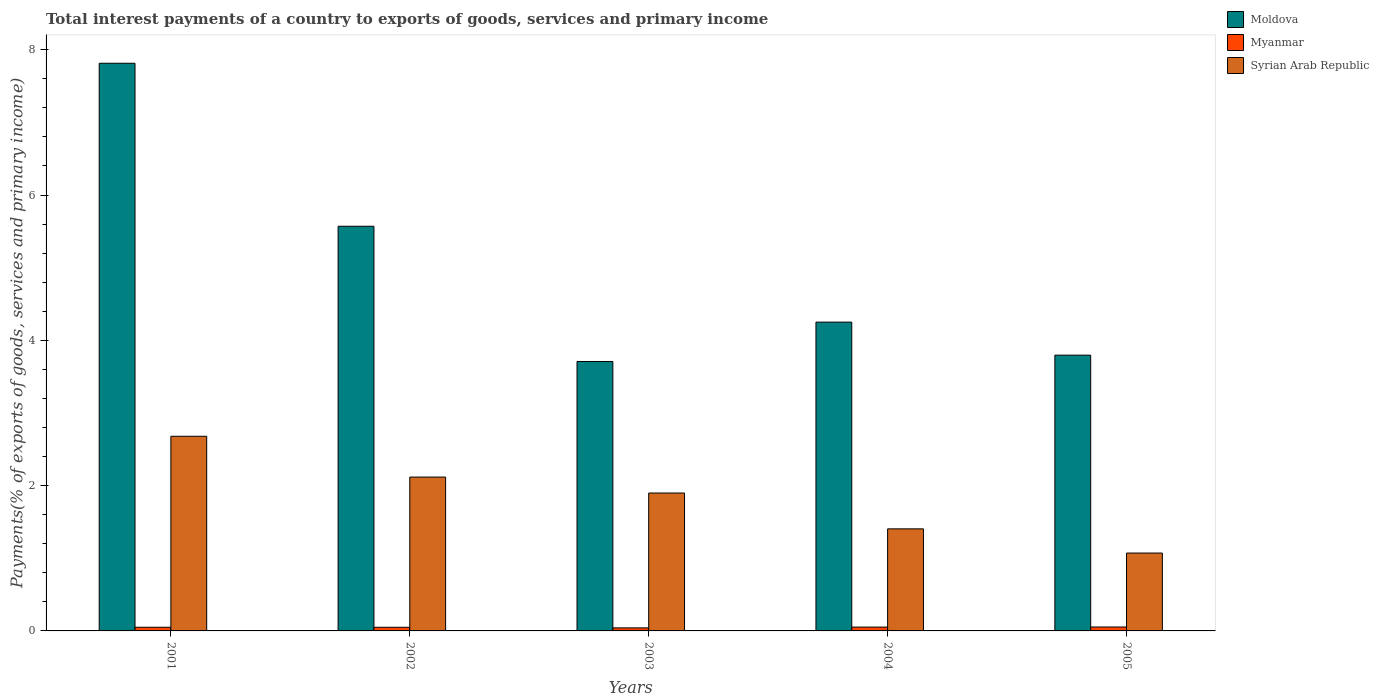How many different coloured bars are there?
Provide a short and direct response. 3. Are the number of bars per tick equal to the number of legend labels?
Your answer should be compact. Yes. Are the number of bars on each tick of the X-axis equal?
Give a very brief answer. Yes. How many bars are there on the 2nd tick from the left?
Keep it short and to the point. 3. What is the total interest payments in Syrian Arab Republic in 2001?
Offer a very short reply. 2.68. Across all years, what is the maximum total interest payments in Myanmar?
Ensure brevity in your answer.  0.05. Across all years, what is the minimum total interest payments in Moldova?
Offer a very short reply. 3.71. What is the total total interest payments in Moldova in the graph?
Make the answer very short. 25.14. What is the difference between the total interest payments in Myanmar in 2002 and that in 2004?
Offer a terse response. -0. What is the difference between the total interest payments in Moldova in 2002 and the total interest payments in Syrian Arab Republic in 2004?
Offer a very short reply. 4.16. What is the average total interest payments in Myanmar per year?
Your answer should be compact. 0.05. In the year 2004, what is the difference between the total interest payments in Myanmar and total interest payments in Moldova?
Your response must be concise. -4.2. In how many years, is the total interest payments in Myanmar greater than 2 %?
Ensure brevity in your answer.  0. What is the ratio of the total interest payments in Syrian Arab Republic in 2003 to that in 2004?
Make the answer very short. 1.35. Is the difference between the total interest payments in Myanmar in 2004 and 2005 greater than the difference between the total interest payments in Moldova in 2004 and 2005?
Your answer should be very brief. No. What is the difference between the highest and the second highest total interest payments in Syrian Arab Republic?
Offer a terse response. 0.56. What is the difference between the highest and the lowest total interest payments in Myanmar?
Your response must be concise. 0.01. In how many years, is the total interest payments in Moldova greater than the average total interest payments in Moldova taken over all years?
Your response must be concise. 2. Is the sum of the total interest payments in Moldova in 2002 and 2004 greater than the maximum total interest payments in Syrian Arab Republic across all years?
Your answer should be compact. Yes. What does the 3rd bar from the left in 2001 represents?
Offer a terse response. Syrian Arab Republic. What does the 1st bar from the right in 2001 represents?
Ensure brevity in your answer.  Syrian Arab Republic. Is it the case that in every year, the sum of the total interest payments in Syrian Arab Republic and total interest payments in Myanmar is greater than the total interest payments in Moldova?
Ensure brevity in your answer.  No. Are all the bars in the graph horizontal?
Offer a very short reply. No. Does the graph contain any zero values?
Make the answer very short. No. Does the graph contain grids?
Keep it short and to the point. No. How are the legend labels stacked?
Your response must be concise. Vertical. What is the title of the graph?
Keep it short and to the point. Total interest payments of a country to exports of goods, services and primary income. What is the label or title of the Y-axis?
Ensure brevity in your answer.  Payments(% of exports of goods, services and primary income). What is the Payments(% of exports of goods, services and primary income) in Moldova in 2001?
Provide a short and direct response. 7.81. What is the Payments(% of exports of goods, services and primary income) of Myanmar in 2001?
Ensure brevity in your answer.  0.05. What is the Payments(% of exports of goods, services and primary income) of Syrian Arab Republic in 2001?
Keep it short and to the point. 2.68. What is the Payments(% of exports of goods, services and primary income) of Moldova in 2002?
Your response must be concise. 5.57. What is the Payments(% of exports of goods, services and primary income) in Myanmar in 2002?
Your answer should be very brief. 0.05. What is the Payments(% of exports of goods, services and primary income) in Syrian Arab Republic in 2002?
Provide a short and direct response. 2.12. What is the Payments(% of exports of goods, services and primary income) in Moldova in 2003?
Offer a terse response. 3.71. What is the Payments(% of exports of goods, services and primary income) of Myanmar in 2003?
Provide a short and direct response. 0.04. What is the Payments(% of exports of goods, services and primary income) in Syrian Arab Republic in 2003?
Provide a short and direct response. 1.9. What is the Payments(% of exports of goods, services and primary income) in Moldova in 2004?
Make the answer very short. 4.25. What is the Payments(% of exports of goods, services and primary income) of Myanmar in 2004?
Your response must be concise. 0.05. What is the Payments(% of exports of goods, services and primary income) of Syrian Arab Republic in 2004?
Provide a succinct answer. 1.4. What is the Payments(% of exports of goods, services and primary income) in Moldova in 2005?
Ensure brevity in your answer.  3.8. What is the Payments(% of exports of goods, services and primary income) in Myanmar in 2005?
Your answer should be compact. 0.05. What is the Payments(% of exports of goods, services and primary income) in Syrian Arab Republic in 2005?
Ensure brevity in your answer.  1.07. Across all years, what is the maximum Payments(% of exports of goods, services and primary income) of Moldova?
Offer a terse response. 7.81. Across all years, what is the maximum Payments(% of exports of goods, services and primary income) of Myanmar?
Give a very brief answer. 0.05. Across all years, what is the maximum Payments(% of exports of goods, services and primary income) of Syrian Arab Republic?
Give a very brief answer. 2.68. Across all years, what is the minimum Payments(% of exports of goods, services and primary income) in Moldova?
Make the answer very short. 3.71. Across all years, what is the minimum Payments(% of exports of goods, services and primary income) of Myanmar?
Provide a succinct answer. 0.04. Across all years, what is the minimum Payments(% of exports of goods, services and primary income) in Syrian Arab Republic?
Make the answer very short. 1.07. What is the total Payments(% of exports of goods, services and primary income) in Moldova in the graph?
Offer a very short reply. 25.14. What is the total Payments(% of exports of goods, services and primary income) in Myanmar in the graph?
Ensure brevity in your answer.  0.25. What is the total Payments(% of exports of goods, services and primary income) in Syrian Arab Republic in the graph?
Your answer should be compact. 9.17. What is the difference between the Payments(% of exports of goods, services and primary income) of Moldova in 2001 and that in 2002?
Offer a very short reply. 2.24. What is the difference between the Payments(% of exports of goods, services and primary income) of Myanmar in 2001 and that in 2002?
Offer a very short reply. 0. What is the difference between the Payments(% of exports of goods, services and primary income) of Syrian Arab Republic in 2001 and that in 2002?
Your answer should be compact. 0.56. What is the difference between the Payments(% of exports of goods, services and primary income) in Moldova in 2001 and that in 2003?
Your answer should be compact. 4.11. What is the difference between the Payments(% of exports of goods, services and primary income) of Myanmar in 2001 and that in 2003?
Keep it short and to the point. 0.01. What is the difference between the Payments(% of exports of goods, services and primary income) in Syrian Arab Republic in 2001 and that in 2003?
Your response must be concise. 0.78. What is the difference between the Payments(% of exports of goods, services and primary income) in Moldova in 2001 and that in 2004?
Offer a very short reply. 3.56. What is the difference between the Payments(% of exports of goods, services and primary income) of Myanmar in 2001 and that in 2004?
Your response must be concise. -0. What is the difference between the Payments(% of exports of goods, services and primary income) of Syrian Arab Republic in 2001 and that in 2004?
Ensure brevity in your answer.  1.27. What is the difference between the Payments(% of exports of goods, services and primary income) in Moldova in 2001 and that in 2005?
Make the answer very short. 4.02. What is the difference between the Payments(% of exports of goods, services and primary income) of Myanmar in 2001 and that in 2005?
Offer a very short reply. -0. What is the difference between the Payments(% of exports of goods, services and primary income) in Syrian Arab Republic in 2001 and that in 2005?
Keep it short and to the point. 1.61. What is the difference between the Payments(% of exports of goods, services and primary income) in Moldova in 2002 and that in 2003?
Your answer should be very brief. 1.86. What is the difference between the Payments(% of exports of goods, services and primary income) of Myanmar in 2002 and that in 2003?
Give a very brief answer. 0.01. What is the difference between the Payments(% of exports of goods, services and primary income) of Syrian Arab Republic in 2002 and that in 2003?
Provide a succinct answer. 0.22. What is the difference between the Payments(% of exports of goods, services and primary income) in Moldova in 2002 and that in 2004?
Provide a short and direct response. 1.32. What is the difference between the Payments(% of exports of goods, services and primary income) in Myanmar in 2002 and that in 2004?
Make the answer very short. -0. What is the difference between the Payments(% of exports of goods, services and primary income) in Syrian Arab Republic in 2002 and that in 2004?
Ensure brevity in your answer.  0.71. What is the difference between the Payments(% of exports of goods, services and primary income) in Moldova in 2002 and that in 2005?
Offer a terse response. 1.77. What is the difference between the Payments(% of exports of goods, services and primary income) in Myanmar in 2002 and that in 2005?
Keep it short and to the point. -0. What is the difference between the Payments(% of exports of goods, services and primary income) of Syrian Arab Republic in 2002 and that in 2005?
Your answer should be compact. 1.05. What is the difference between the Payments(% of exports of goods, services and primary income) of Moldova in 2003 and that in 2004?
Keep it short and to the point. -0.54. What is the difference between the Payments(% of exports of goods, services and primary income) in Myanmar in 2003 and that in 2004?
Offer a terse response. -0.01. What is the difference between the Payments(% of exports of goods, services and primary income) in Syrian Arab Republic in 2003 and that in 2004?
Ensure brevity in your answer.  0.49. What is the difference between the Payments(% of exports of goods, services and primary income) in Moldova in 2003 and that in 2005?
Offer a terse response. -0.09. What is the difference between the Payments(% of exports of goods, services and primary income) in Myanmar in 2003 and that in 2005?
Provide a succinct answer. -0.01. What is the difference between the Payments(% of exports of goods, services and primary income) in Syrian Arab Republic in 2003 and that in 2005?
Give a very brief answer. 0.83. What is the difference between the Payments(% of exports of goods, services and primary income) of Moldova in 2004 and that in 2005?
Offer a very short reply. 0.45. What is the difference between the Payments(% of exports of goods, services and primary income) in Myanmar in 2004 and that in 2005?
Keep it short and to the point. -0. What is the difference between the Payments(% of exports of goods, services and primary income) in Syrian Arab Republic in 2004 and that in 2005?
Keep it short and to the point. 0.33. What is the difference between the Payments(% of exports of goods, services and primary income) in Moldova in 2001 and the Payments(% of exports of goods, services and primary income) in Myanmar in 2002?
Provide a short and direct response. 7.76. What is the difference between the Payments(% of exports of goods, services and primary income) of Moldova in 2001 and the Payments(% of exports of goods, services and primary income) of Syrian Arab Republic in 2002?
Provide a short and direct response. 5.7. What is the difference between the Payments(% of exports of goods, services and primary income) in Myanmar in 2001 and the Payments(% of exports of goods, services and primary income) in Syrian Arab Republic in 2002?
Your response must be concise. -2.07. What is the difference between the Payments(% of exports of goods, services and primary income) of Moldova in 2001 and the Payments(% of exports of goods, services and primary income) of Myanmar in 2003?
Make the answer very short. 7.77. What is the difference between the Payments(% of exports of goods, services and primary income) of Moldova in 2001 and the Payments(% of exports of goods, services and primary income) of Syrian Arab Republic in 2003?
Ensure brevity in your answer.  5.92. What is the difference between the Payments(% of exports of goods, services and primary income) in Myanmar in 2001 and the Payments(% of exports of goods, services and primary income) in Syrian Arab Republic in 2003?
Keep it short and to the point. -1.85. What is the difference between the Payments(% of exports of goods, services and primary income) of Moldova in 2001 and the Payments(% of exports of goods, services and primary income) of Myanmar in 2004?
Provide a short and direct response. 7.76. What is the difference between the Payments(% of exports of goods, services and primary income) in Moldova in 2001 and the Payments(% of exports of goods, services and primary income) in Syrian Arab Republic in 2004?
Keep it short and to the point. 6.41. What is the difference between the Payments(% of exports of goods, services and primary income) in Myanmar in 2001 and the Payments(% of exports of goods, services and primary income) in Syrian Arab Republic in 2004?
Keep it short and to the point. -1.35. What is the difference between the Payments(% of exports of goods, services and primary income) of Moldova in 2001 and the Payments(% of exports of goods, services and primary income) of Myanmar in 2005?
Provide a short and direct response. 7.76. What is the difference between the Payments(% of exports of goods, services and primary income) in Moldova in 2001 and the Payments(% of exports of goods, services and primary income) in Syrian Arab Republic in 2005?
Your answer should be very brief. 6.74. What is the difference between the Payments(% of exports of goods, services and primary income) in Myanmar in 2001 and the Payments(% of exports of goods, services and primary income) in Syrian Arab Republic in 2005?
Provide a succinct answer. -1.02. What is the difference between the Payments(% of exports of goods, services and primary income) of Moldova in 2002 and the Payments(% of exports of goods, services and primary income) of Myanmar in 2003?
Make the answer very short. 5.53. What is the difference between the Payments(% of exports of goods, services and primary income) in Moldova in 2002 and the Payments(% of exports of goods, services and primary income) in Syrian Arab Republic in 2003?
Give a very brief answer. 3.67. What is the difference between the Payments(% of exports of goods, services and primary income) in Myanmar in 2002 and the Payments(% of exports of goods, services and primary income) in Syrian Arab Republic in 2003?
Offer a very short reply. -1.85. What is the difference between the Payments(% of exports of goods, services and primary income) of Moldova in 2002 and the Payments(% of exports of goods, services and primary income) of Myanmar in 2004?
Your response must be concise. 5.52. What is the difference between the Payments(% of exports of goods, services and primary income) of Moldova in 2002 and the Payments(% of exports of goods, services and primary income) of Syrian Arab Republic in 2004?
Keep it short and to the point. 4.17. What is the difference between the Payments(% of exports of goods, services and primary income) in Myanmar in 2002 and the Payments(% of exports of goods, services and primary income) in Syrian Arab Republic in 2004?
Your answer should be compact. -1.35. What is the difference between the Payments(% of exports of goods, services and primary income) of Moldova in 2002 and the Payments(% of exports of goods, services and primary income) of Myanmar in 2005?
Provide a succinct answer. 5.52. What is the difference between the Payments(% of exports of goods, services and primary income) in Moldova in 2002 and the Payments(% of exports of goods, services and primary income) in Syrian Arab Republic in 2005?
Make the answer very short. 4.5. What is the difference between the Payments(% of exports of goods, services and primary income) of Myanmar in 2002 and the Payments(% of exports of goods, services and primary income) of Syrian Arab Republic in 2005?
Offer a very short reply. -1.02. What is the difference between the Payments(% of exports of goods, services and primary income) in Moldova in 2003 and the Payments(% of exports of goods, services and primary income) in Myanmar in 2004?
Your answer should be compact. 3.66. What is the difference between the Payments(% of exports of goods, services and primary income) of Moldova in 2003 and the Payments(% of exports of goods, services and primary income) of Syrian Arab Republic in 2004?
Your answer should be very brief. 2.3. What is the difference between the Payments(% of exports of goods, services and primary income) in Myanmar in 2003 and the Payments(% of exports of goods, services and primary income) in Syrian Arab Republic in 2004?
Offer a terse response. -1.36. What is the difference between the Payments(% of exports of goods, services and primary income) of Moldova in 2003 and the Payments(% of exports of goods, services and primary income) of Myanmar in 2005?
Offer a very short reply. 3.65. What is the difference between the Payments(% of exports of goods, services and primary income) of Moldova in 2003 and the Payments(% of exports of goods, services and primary income) of Syrian Arab Republic in 2005?
Your answer should be very brief. 2.64. What is the difference between the Payments(% of exports of goods, services and primary income) in Myanmar in 2003 and the Payments(% of exports of goods, services and primary income) in Syrian Arab Republic in 2005?
Your response must be concise. -1.03. What is the difference between the Payments(% of exports of goods, services and primary income) of Moldova in 2004 and the Payments(% of exports of goods, services and primary income) of Myanmar in 2005?
Offer a very short reply. 4.2. What is the difference between the Payments(% of exports of goods, services and primary income) of Moldova in 2004 and the Payments(% of exports of goods, services and primary income) of Syrian Arab Republic in 2005?
Make the answer very short. 3.18. What is the difference between the Payments(% of exports of goods, services and primary income) of Myanmar in 2004 and the Payments(% of exports of goods, services and primary income) of Syrian Arab Republic in 2005?
Offer a very short reply. -1.02. What is the average Payments(% of exports of goods, services and primary income) of Moldova per year?
Offer a very short reply. 5.03. What is the average Payments(% of exports of goods, services and primary income) in Myanmar per year?
Provide a succinct answer. 0.05. What is the average Payments(% of exports of goods, services and primary income) of Syrian Arab Republic per year?
Your answer should be very brief. 1.83. In the year 2001, what is the difference between the Payments(% of exports of goods, services and primary income) in Moldova and Payments(% of exports of goods, services and primary income) in Myanmar?
Keep it short and to the point. 7.76. In the year 2001, what is the difference between the Payments(% of exports of goods, services and primary income) of Moldova and Payments(% of exports of goods, services and primary income) of Syrian Arab Republic?
Provide a short and direct response. 5.13. In the year 2001, what is the difference between the Payments(% of exports of goods, services and primary income) in Myanmar and Payments(% of exports of goods, services and primary income) in Syrian Arab Republic?
Ensure brevity in your answer.  -2.63. In the year 2002, what is the difference between the Payments(% of exports of goods, services and primary income) in Moldova and Payments(% of exports of goods, services and primary income) in Myanmar?
Provide a succinct answer. 5.52. In the year 2002, what is the difference between the Payments(% of exports of goods, services and primary income) of Moldova and Payments(% of exports of goods, services and primary income) of Syrian Arab Republic?
Ensure brevity in your answer.  3.45. In the year 2002, what is the difference between the Payments(% of exports of goods, services and primary income) in Myanmar and Payments(% of exports of goods, services and primary income) in Syrian Arab Republic?
Provide a short and direct response. -2.07. In the year 2003, what is the difference between the Payments(% of exports of goods, services and primary income) of Moldova and Payments(% of exports of goods, services and primary income) of Myanmar?
Make the answer very short. 3.67. In the year 2003, what is the difference between the Payments(% of exports of goods, services and primary income) in Moldova and Payments(% of exports of goods, services and primary income) in Syrian Arab Republic?
Your answer should be very brief. 1.81. In the year 2003, what is the difference between the Payments(% of exports of goods, services and primary income) in Myanmar and Payments(% of exports of goods, services and primary income) in Syrian Arab Republic?
Make the answer very short. -1.86. In the year 2004, what is the difference between the Payments(% of exports of goods, services and primary income) of Moldova and Payments(% of exports of goods, services and primary income) of Myanmar?
Your answer should be compact. 4.2. In the year 2004, what is the difference between the Payments(% of exports of goods, services and primary income) in Moldova and Payments(% of exports of goods, services and primary income) in Syrian Arab Republic?
Offer a very short reply. 2.85. In the year 2004, what is the difference between the Payments(% of exports of goods, services and primary income) in Myanmar and Payments(% of exports of goods, services and primary income) in Syrian Arab Republic?
Your response must be concise. -1.35. In the year 2005, what is the difference between the Payments(% of exports of goods, services and primary income) of Moldova and Payments(% of exports of goods, services and primary income) of Myanmar?
Ensure brevity in your answer.  3.74. In the year 2005, what is the difference between the Payments(% of exports of goods, services and primary income) of Moldova and Payments(% of exports of goods, services and primary income) of Syrian Arab Republic?
Make the answer very short. 2.72. In the year 2005, what is the difference between the Payments(% of exports of goods, services and primary income) of Myanmar and Payments(% of exports of goods, services and primary income) of Syrian Arab Republic?
Your answer should be very brief. -1.02. What is the ratio of the Payments(% of exports of goods, services and primary income) of Moldova in 2001 to that in 2002?
Ensure brevity in your answer.  1.4. What is the ratio of the Payments(% of exports of goods, services and primary income) in Myanmar in 2001 to that in 2002?
Ensure brevity in your answer.  1.01. What is the ratio of the Payments(% of exports of goods, services and primary income) of Syrian Arab Republic in 2001 to that in 2002?
Give a very brief answer. 1.27. What is the ratio of the Payments(% of exports of goods, services and primary income) of Moldova in 2001 to that in 2003?
Ensure brevity in your answer.  2.11. What is the ratio of the Payments(% of exports of goods, services and primary income) in Myanmar in 2001 to that in 2003?
Give a very brief answer. 1.2. What is the ratio of the Payments(% of exports of goods, services and primary income) of Syrian Arab Republic in 2001 to that in 2003?
Ensure brevity in your answer.  1.41. What is the ratio of the Payments(% of exports of goods, services and primary income) of Moldova in 2001 to that in 2004?
Ensure brevity in your answer.  1.84. What is the ratio of the Payments(% of exports of goods, services and primary income) of Myanmar in 2001 to that in 2004?
Provide a short and direct response. 0.96. What is the ratio of the Payments(% of exports of goods, services and primary income) in Syrian Arab Republic in 2001 to that in 2004?
Your answer should be very brief. 1.91. What is the ratio of the Payments(% of exports of goods, services and primary income) of Moldova in 2001 to that in 2005?
Give a very brief answer. 2.06. What is the ratio of the Payments(% of exports of goods, services and primary income) of Myanmar in 2001 to that in 2005?
Offer a very short reply. 0.93. What is the ratio of the Payments(% of exports of goods, services and primary income) in Syrian Arab Republic in 2001 to that in 2005?
Your answer should be very brief. 2.5. What is the ratio of the Payments(% of exports of goods, services and primary income) in Moldova in 2002 to that in 2003?
Your response must be concise. 1.5. What is the ratio of the Payments(% of exports of goods, services and primary income) in Myanmar in 2002 to that in 2003?
Keep it short and to the point. 1.2. What is the ratio of the Payments(% of exports of goods, services and primary income) of Syrian Arab Republic in 2002 to that in 2003?
Offer a very short reply. 1.12. What is the ratio of the Payments(% of exports of goods, services and primary income) of Moldova in 2002 to that in 2004?
Provide a short and direct response. 1.31. What is the ratio of the Payments(% of exports of goods, services and primary income) of Myanmar in 2002 to that in 2004?
Make the answer very short. 0.95. What is the ratio of the Payments(% of exports of goods, services and primary income) in Syrian Arab Republic in 2002 to that in 2004?
Make the answer very short. 1.51. What is the ratio of the Payments(% of exports of goods, services and primary income) in Moldova in 2002 to that in 2005?
Your response must be concise. 1.47. What is the ratio of the Payments(% of exports of goods, services and primary income) in Myanmar in 2002 to that in 2005?
Give a very brief answer. 0.93. What is the ratio of the Payments(% of exports of goods, services and primary income) of Syrian Arab Republic in 2002 to that in 2005?
Offer a terse response. 1.98. What is the ratio of the Payments(% of exports of goods, services and primary income) of Moldova in 2003 to that in 2004?
Give a very brief answer. 0.87. What is the ratio of the Payments(% of exports of goods, services and primary income) in Myanmar in 2003 to that in 2004?
Give a very brief answer. 0.8. What is the ratio of the Payments(% of exports of goods, services and primary income) in Syrian Arab Republic in 2003 to that in 2004?
Give a very brief answer. 1.35. What is the ratio of the Payments(% of exports of goods, services and primary income) in Moldova in 2003 to that in 2005?
Your answer should be very brief. 0.98. What is the ratio of the Payments(% of exports of goods, services and primary income) of Myanmar in 2003 to that in 2005?
Provide a short and direct response. 0.78. What is the ratio of the Payments(% of exports of goods, services and primary income) of Syrian Arab Republic in 2003 to that in 2005?
Offer a very short reply. 1.77. What is the ratio of the Payments(% of exports of goods, services and primary income) in Moldova in 2004 to that in 2005?
Ensure brevity in your answer.  1.12. What is the ratio of the Payments(% of exports of goods, services and primary income) of Myanmar in 2004 to that in 2005?
Ensure brevity in your answer.  0.98. What is the ratio of the Payments(% of exports of goods, services and primary income) in Syrian Arab Republic in 2004 to that in 2005?
Ensure brevity in your answer.  1.31. What is the difference between the highest and the second highest Payments(% of exports of goods, services and primary income) of Moldova?
Give a very brief answer. 2.24. What is the difference between the highest and the second highest Payments(% of exports of goods, services and primary income) in Myanmar?
Your answer should be very brief. 0. What is the difference between the highest and the second highest Payments(% of exports of goods, services and primary income) of Syrian Arab Republic?
Your answer should be very brief. 0.56. What is the difference between the highest and the lowest Payments(% of exports of goods, services and primary income) in Moldova?
Ensure brevity in your answer.  4.11. What is the difference between the highest and the lowest Payments(% of exports of goods, services and primary income) of Myanmar?
Your response must be concise. 0.01. What is the difference between the highest and the lowest Payments(% of exports of goods, services and primary income) of Syrian Arab Republic?
Your response must be concise. 1.61. 